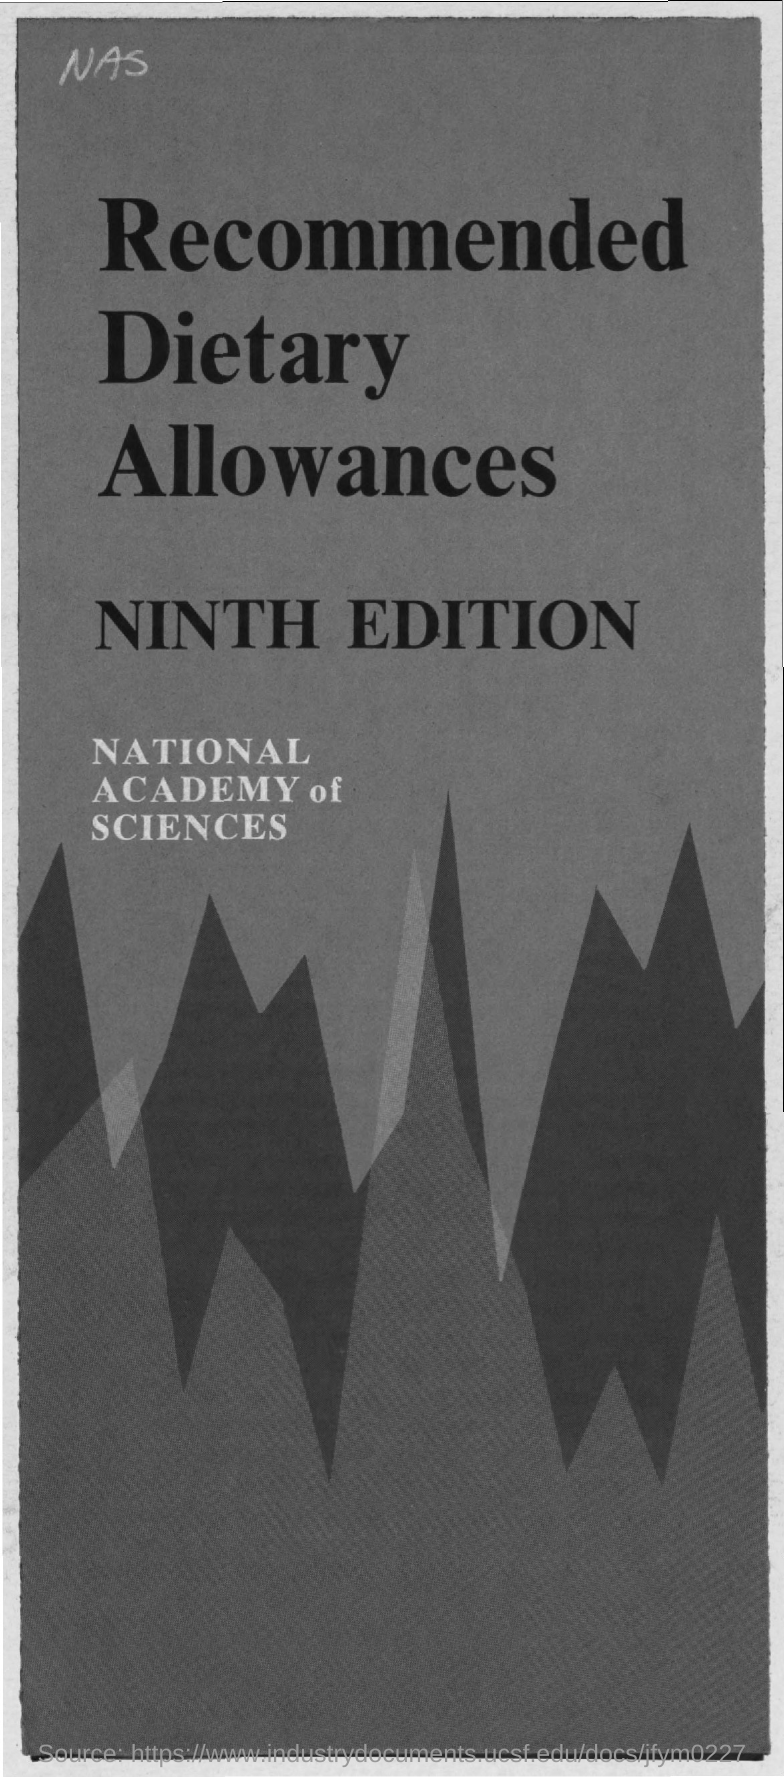What is the number of edition mentioned ?
Your answer should be very brief. Ninth edition. What is the name of allowances mentioned ?
Make the answer very short. RECOMMENDED DIETARY ALLOWANCES. What is the name of the academy mentioned ?
Your answer should be very brief. National academy of sciences. 